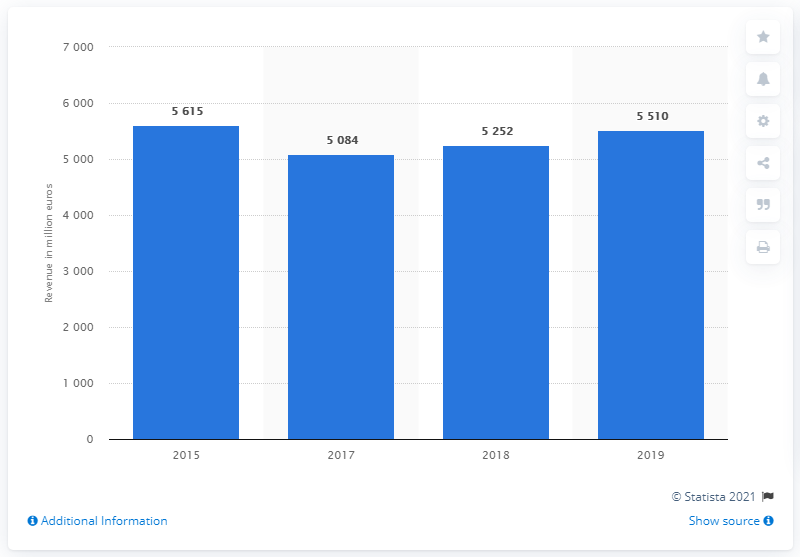Outline some significant characteristics in this image. According to recent data, the combined revenue of the fitness markets in Germany and the UK is approximately 5,510. 